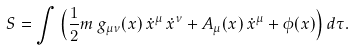Convert formula to latex. <formula><loc_0><loc_0><loc_500><loc_500>S = \int \left ( \frac { 1 } { 2 } m \, g _ { \mu \nu } ( x ) \, \dot { x } ^ { \mu } \, \dot { x } ^ { \nu } + A _ { \mu } ( x ) \, \dot { x } ^ { \mu } + \phi ( x ) \right ) d \tau .</formula> 